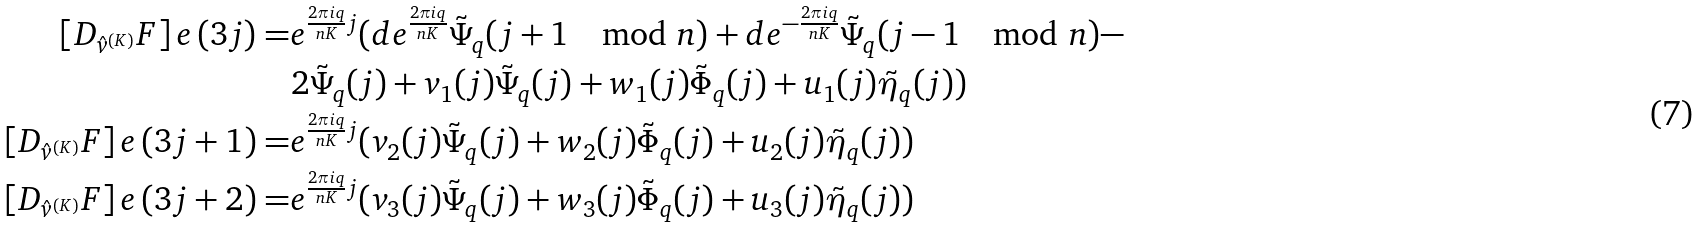Convert formula to latex. <formula><loc_0><loc_0><loc_500><loc_500>\left [ D _ { \hat { v } ^ { ( K ) } } F \right ] e \, ( 3 j ) = & e ^ { \frac { 2 \pi i q } { n K } j } ( d e ^ { \frac { 2 \pi i q } { n K } } \tilde { \Psi } _ { q } ( j + 1 \, \mod n ) + d e ^ { - \frac { 2 \pi i q } { n K } } \tilde { \Psi } _ { q } ( j - 1 \, \mod n ) - \\ & 2 \tilde { \Psi } _ { q } ( j ) + v _ { 1 } ( j ) \tilde { \Psi } _ { q } ( j ) + w _ { 1 } ( j ) \tilde { \Phi } _ { q } ( j ) + u _ { 1 } ( j ) \tilde { \eta } _ { q } ( j ) ) \\ \left [ D _ { \hat { v } ^ { ( K ) } } F \right ] e \, ( 3 j + 1 ) = & e ^ { \frac { 2 \pi i q } { n K } j } ( v _ { 2 } ( j ) \tilde { \Psi } _ { q } ( j ) + w _ { 2 } ( j ) \tilde { \Phi } _ { q } ( j ) + u _ { 2 } ( j ) \tilde { \eta } _ { q } ( j ) ) \\ \left [ D _ { \hat { v } ^ { ( K ) } } F \right ] e \, ( 3 j + 2 ) = & e ^ { \frac { 2 \pi i q } { n K } j } ( v _ { 3 } ( j ) \tilde { \Psi } _ { q } ( j ) + w _ { 3 } ( j ) \tilde { \Phi } _ { q } ( j ) + u _ { 3 } ( j ) \tilde { \eta } _ { q } ( j ) )</formula> 